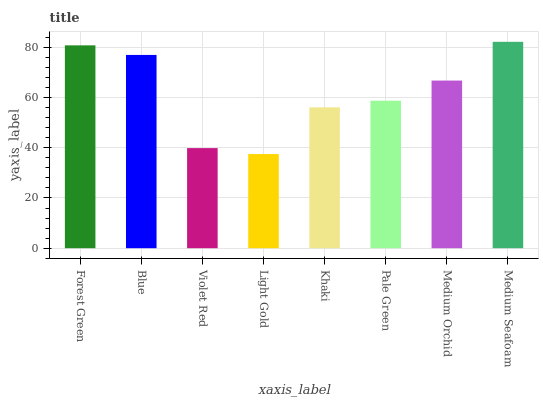Is Light Gold the minimum?
Answer yes or no. Yes. Is Medium Seafoam the maximum?
Answer yes or no. Yes. Is Blue the minimum?
Answer yes or no. No. Is Blue the maximum?
Answer yes or no. No. Is Forest Green greater than Blue?
Answer yes or no. Yes. Is Blue less than Forest Green?
Answer yes or no. Yes. Is Blue greater than Forest Green?
Answer yes or no. No. Is Forest Green less than Blue?
Answer yes or no. No. Is Medium Orchid the high median?
Answer yes or no. Yes. Is Pale Green the low median?
Answer yes or no. Yes. Is Khaki the high median?
Answer yes or no. No. Is Medium Orchid the low median?
Answer yes or no. No. 